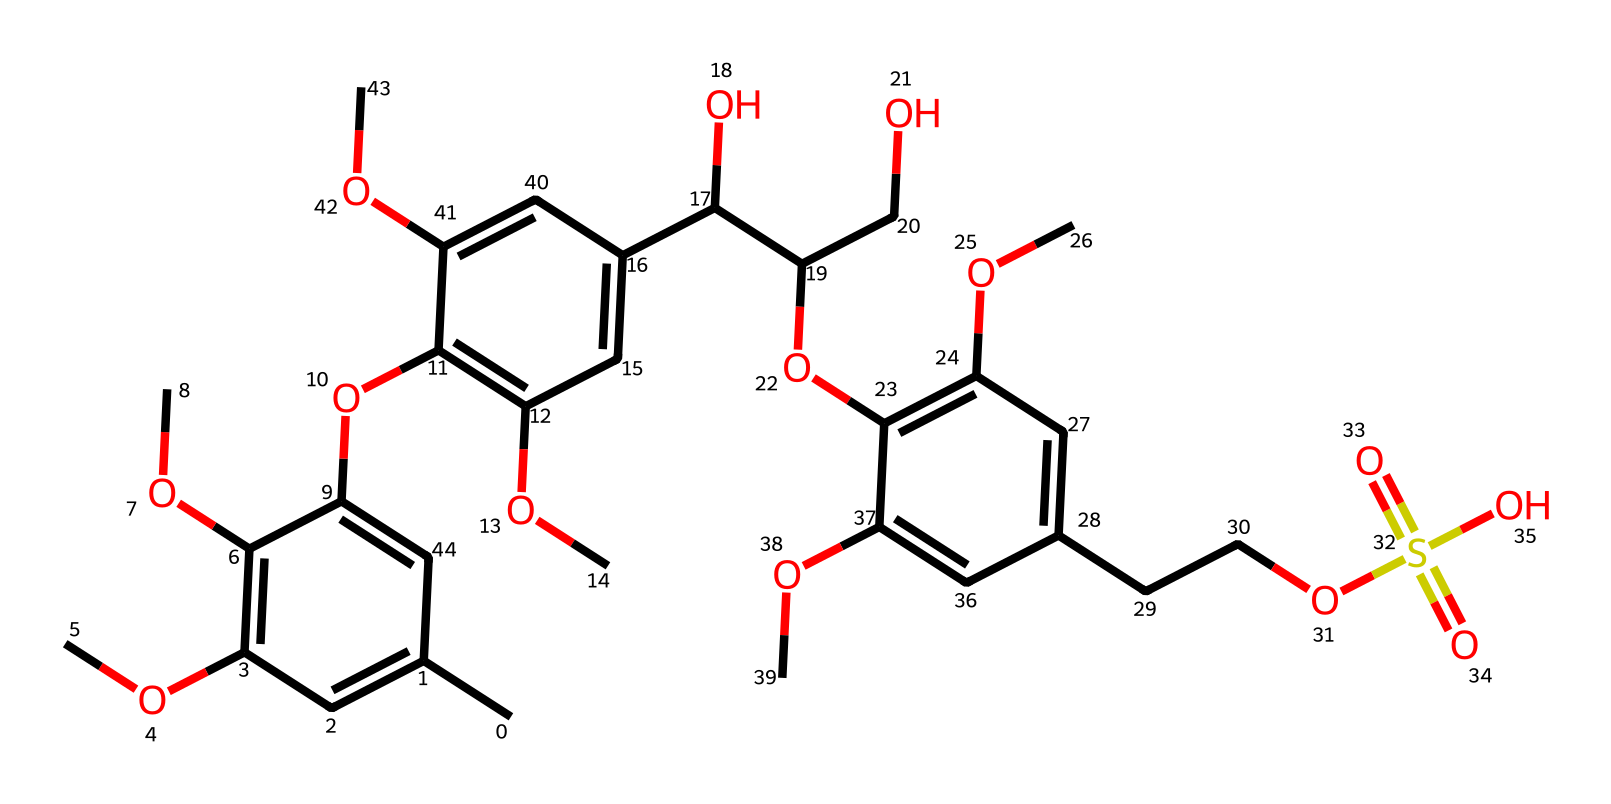What is the total number of carbon atoms in this molecule? To find the total number of carbon atoms, I count each carbon atom represented in the chemical structure. By visual inspection of the SMILES, I see that there are 21 carbon atoms in total.
Answer: 21 How many methoxy groups are present in this molecule? Methoxy groups are indicated by the -OCH3 groups in the structure. Upon examining the SMILES, I identify three methoxy groups attached to various carbon atoms.
Answer: 3 What type of polymer is represented by this structure? The structure contains multiple aromatic rings and numerous ether linkages, indicating it is a lignin polymer. This classification is based on the overall structure reflecting characteristics typical of lignin.
Answer: lignin Which functional groups are primarily found in this molecule? By analyzing the structure, I can identify several functional groups including methoxy (-OCH3), hydroxyl (-OH), and sulfonic acid (-SO3H) groups. This determination is made by looking at the distinctive features in the SMILES.
Answer: methoxy, hydroxyl, sulfonic acid What is the degree of polymerization represented by this molecule? The degree of polymerization refers to the number of repeating units or monomers within the polymer. In this case, by assessing the complexity and connectivity of the long chain visible in the structure, the degree of polymerization is determined to be high, represented by multiple interconnected units.
Answer: high 